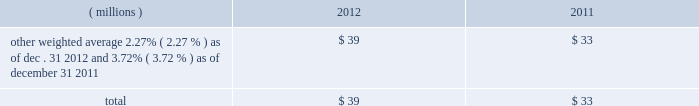2012 ppg annual report and form 10-k 45 costs related to these notes , which totaled $ 17 million , will be amortized to interest expense over the respective terms of the notes .
In august 2010 , ppg entered into a three-year credit agreement with several banks and financial institutions ( the "2010 credit agreement" ) which was subsequently terminated in july 2012 .
The 2010 credit agreement provided for a $ 1.2 billion unsecured revolving credit facility .
In connection with entering into the 2010 credit agreement , the company terminated its 20ac650 million and its $ 1 billion revolving credit facilities that were each set to expire in 2011 .
There were no outstanding amounts due under either revolving facility at the times of their termination .
The 2010 credit agreement was set to terminate on august 5 , 2013 .
Ppg 2019s non-u.s .
Operations have uncommitted lines of credit totaling $ 705 million of which $ 34 million was used as of december 31 , 2012 .
These uncommitted lines of credit are subject to cancellation at any time and are generally not subject to any commitment fees .
Short-term debt outstanding as of december 31 , 2012 and 2011 , was as follows: .
Ppg is in compliance with the restrictive covenants under its various credit agreements , loan agreements and indentures .
The company 2019s revolving credit agreements include a financial ratio covenant .
The covenant requires that the amount of total indebtedness not exceed 60% ( 60 % ) of the company 2019s total capitalization excluding the portion of accumulated other comprehensive income ( loss ) related to pensions and other postretirement benefit adjustments .
As of december 31 , 2012 , total indebtedness was 42% ( 42 % ) of the company 2019s total capitalization excluding the portion of accumulated other comprehensive income ( loss ) related to pensions and other postretirement benefit adjustments .
Additionally , substantially all of the company 2019s debt agreements contain customary cross- default provisions .
Those provisions generally provide that a default on a debt service payment of $ 10 million or more for longer than the grace period provided ( usually 10 days ) under one agreement may result in an event of default under other agreements .
None of the company 2019s primary debt obligations are secured or guaranteed by the company 2019s affiliates .
Interest payments in 2012 , 2011 and 2010 totaled $ 219 million , $ 212 million and $ 189 million , respectively .
In october 2009 , the company entered into an agreement with a counterparty to repurchase up to 1.2 million shares of the company 2019s stock of which 1.1 million shares were purchased in the open market ( 465006 of these shares were purchased as of december 31 , 2009 at a weighted average price of $ 56.66 per share ) .
The counterparty held the shares until september of 2010 when the company paid $ 65 million and took possession of these shares .
Rental expense for operating leases was $ 233 million , $ 249 million and $ 233 million in 2012 , 2011 and 2010 , respectively .
The primary leased assets include paint stores , transportation equipment , warehouses and other distribution facilities , and office space , including the company 2019s corporate headquarters located in pittsburgh , pa .
Minimum lease commitments for operating leases that have initial or remaining lease terms in excess of one year as of december 31 , 2012 , are ( in millions ) $ 171 in 2013 , $ 135 in 2014 , $ 107 in 2015 , $ 83 in 2016 , $ 64 in 2017 and $ 135 thereafter .
The company had outstanding letters of credit and surety bonds of $ 119 million as of december 31 , 2012 .
The letters of credit secure the company 2019s performance to third parties under certain self-insurance programs and other commitments made in the ordinary course of business .
As of december 31 , 2012 and 2011 , guarantees outstanding were $ 96 million and $ 90 million , respectively .
The guarantees relate primarily to debt of certain entities in which ppg has an ownership interest and selected customers of certain of the company 2019s businesses .
A portion of such debt is secured by the assets of the related entities .
The carrying values of these guarantees were $ 11 million and $ 13 million as of december 31 , 2012 and 2011 , respectively , and the fair values were $ 11 million and $ 21 million , as of december 31 , 2012 and 2011 , respectively .
The fair value of each guarantee was estimated by comparing the net present value of two hypothetical cash flow streams , one based on ppg 2019s incremental borrowing rate and the other based on the borrower 2019s incremental borrowing rate , as of the effective date of the guarantee .
Both streams were discounted at a risk free rate of return .
The company does not believe any loss related to these letters of credit , surety bonds or guarantees is likely .
Fair value measurement the accounting guidance on fair value measurements establishes a hierarchy with three levels of inputs used to determine fair value .
Level 1 inputs are quoted prices ( unadjusted ) in active markets for identical assets and liabilities , are considered to be the most reliable evidence of fair value , and should be used whenever available .
Level 2 inputs are observable prices that are not quoted on active exchanges .
Level 3 inputs are unobservable inputs employed for measuring the fair value of assets or liabilities .
Table of contents notes to the consolidated financial statements .
As of december 31 , 2012 , how much room does the company have in its restrictive covenant regarding debt to total capitalization? 
Rationale: room - remaining covenant
Computations: (60% - 42%)
Answer: 0.18. 2012 ppg annual report and form 10-k 45 costs related to these notes , which totaled $ 17 million , will be amortized to interest expense over the respective terms of the notes .
In august 2010 , ppg entered into a three-year credit agreement with several banks and financial institutions ( the "2010 credit agreement" ) which was subsequently terminated in july 2012 .
The 2010 credit agreement provided for a $ 1.2 billion unsecured revolving credit facility .
In connection with entering into the 2010 credit agreement , the company terminated its 20ac650 million and its $ 1 billion revolving credit facilities that were each set to expire in 2011 .
There were no outstanding amounts due under either revolving facility at the times of their termination .
The 2010 credit agreement was set to terminate on august 5 , 2013 .
Ppg 2019s non-u.s .
Operations have uncommitted lines of credit totaling $ 705 million of which $ 34 million was used as of december 31 , 2012 .
These uncommitted lines of credit are subject to cancellation at any time and are generally not subject to any commitment fees .
Short-term debt outstanding as of december 31 , 2012 and 2011 , was as follows: .
Ppg is in compliance with the restrictive covenants under its various credit agreements , loan agreements and indentures .
The company 2019s revolving credit agreements include a financial ratio covenant .
The covenant requires that the amount of total indebtedness not exceed 60% ( 60 % ) of the company 2019s total capitalization excluding the portion of accumulated other comprehensive income ( loss ) related to pensions and other postretirement benefit adjustments .
As of december 31 , 2012 , total indebtedness was 42% ( 42 % ) of the company 2019s total capitalization excluding the portion of accumulated other comprehensive income ( loss ) related to pensions and other postretirement benefit adjustments .
Additionally , substantially all of the company 2019s debt agreements contain customary cross- default provisions .
Those provisions generally provide that a default on a debt service payment of $ 10 million or more for longer than the grace period provided ( usually 10 days ) under one agreement may result in an event of default under other agreements .
None of the company 2019s primary debt obligations are secured or guaranteed by the company 2019s affiliates .
Interest payments in 2012 , 2011 and 2010 totaled $ 219 million , $ 212 million and $ 189 million , respectively .
In october 2009 , the company entered into an agreement with a counterparty to repurchase up to 1.2 million shares of the company 2019s stock of which 1.1 million shares were purchased in the open market ( 465006 of these shares were purchased as of december 31 , 2009 at a weighted average price of $ 56.66 per share ) .
The counterparty held the shares until september of 2010 when the company paid $ 65 million and took possession of these shares .
Rental expense for operating leases was $ 233 million , $ 249 million and $ 233 million in 2012 , 2011 and 2010 , respectively .
The primary leased assets include paint stores , transportation equipment , warehouses and other distribution facilities , and office space , including the company 2019s corporate headquarters located in pittsburgh , pa .
Minimum lease commitments for operating leases that have initial or remaining lease terms in excess of one year as of december 31 , 2012 , are ( in millions ) $ 171 in 2013 , $ 135 in 2014 , $ 107 in 2015 , $ 83 in 2016 , $ 64 in 2017 and $ 135 thereafter .
The company had outstanding letters of credit and surety bonds of $ 119 million as of december 31 , 2012 .
The letters of credit secure the company 2019s performance to third parties under certain self-insurance programs and other commitments made in the ordinary course of business .
As of december 31 , 2012 and 2011 , guarantees outstanding were $ 96 million and $ 90 million , respectively .
The guarantees relate primarily to debt of certain entities in which ppg has an ownership interest and selected customers of certain of the company 2019s businesses .
A portion of such debt is secured by the assets of the related entities .
The carrying values of these guarantees were $ 11 million and $ 13 million as of december 31 , 2012 and 2011 , respectively , and the fair values were $ 11 million and $ 21 million , as of december 31 , 2012 and 2011 , respectively .
The fair value of each guarantee was estimated by comparing the net present value of two hypothetical cash flow streams , one based on ppg 2019s incremental borrowing rate and the other based on the borrower 2019s incremental borrowing rate , as of the effective date of the guarantee .
Both streams were discounted at a risk free rate of return .
The company does not believe any loss related to these letters of credit , surety bonds or guarantees is likely .
Fair value measurement the accounting guidance on fair value measurements establishes a hierarchy with three levels of inputs used to determine fair value .
Level 1 inputs are quoted prices ( unadjusted ) in active markets for identical assets and liabilities , are considered to be the most reliable evidence of fair value , and should be used whenever available .
Level 2 inputs are observable prices that are not quoted on active exchanges .
Level 3 inputs are unobservable inputs employed for measuring the fair value of assets or liabilities .
Table of contents notes to the consolidated financial statements .
What was the change in millions of rental expense for operating leases from 2010 to 2011? 
Computations: (249 - 233)
Answer: 16.0. 